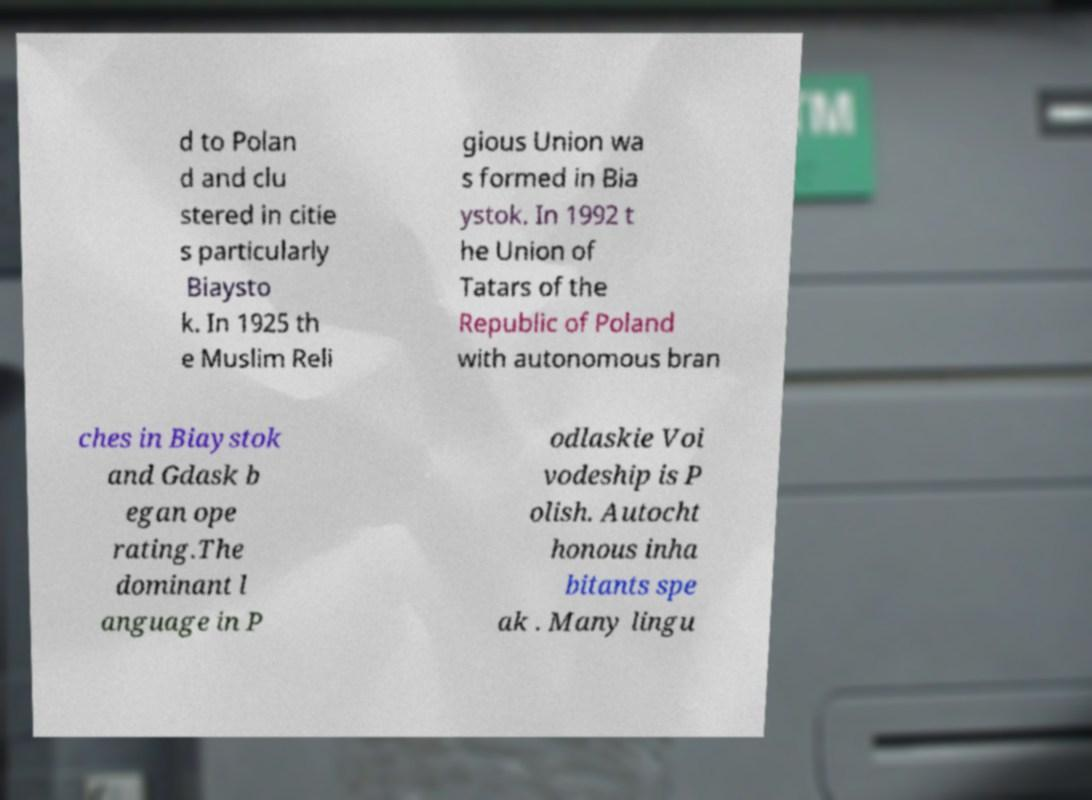Please identify and transcribe the text found in this image. d to Polan d and clu stered in citie s particularly Biaysto k. In 1925 th e Muslim Reli gious Union wa s formed in Bia ystok. In 1992 t he Union of Tatars of the Republic of Poland with autonomous bran ches in Biaystok and Gdask b egan ope rating.The dominant l anguage in P odlaskie Voi vodeship is P olish. Autocht honous inha bitants spe ak . Many lingu 